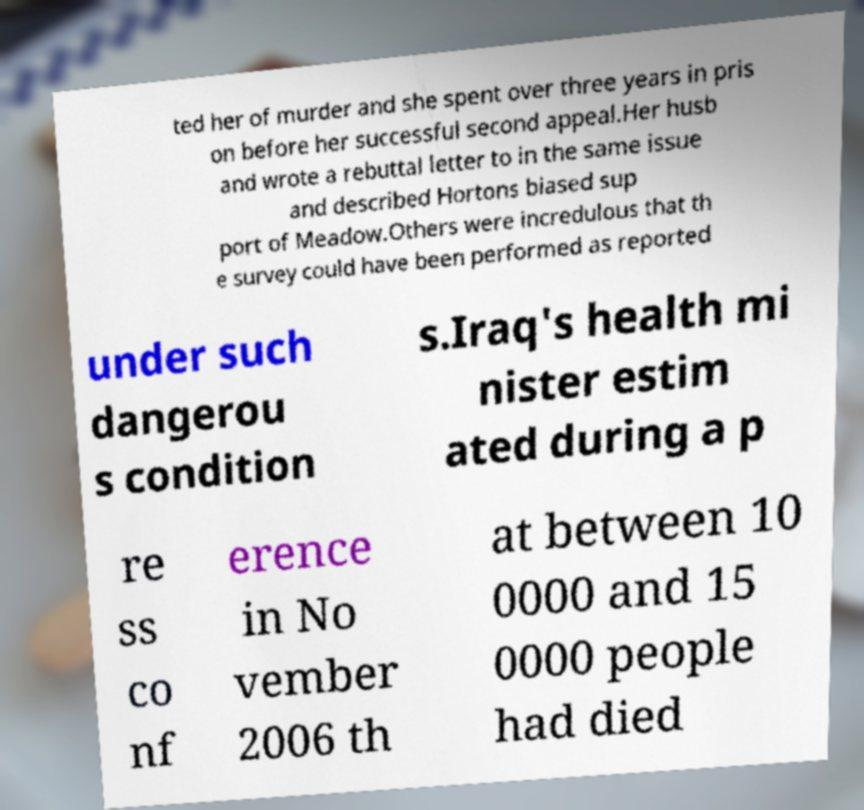What messages or text are displayed in this image? I need them in a readable, typed format. ted her of murder and she spent over three years in pris on before her successful second appeal.Her husb and wrote a rebuttal letter to in the same issue and described Hortons biased sup port of Meadow.Others were incredulous that th e survey could have been performed as reported under such dangerou s condition s.Iraq's health mi nister estim ated during a p re ss co nf erence in No vember 2006 th at between 10 0000 and 15 0000 people had died 